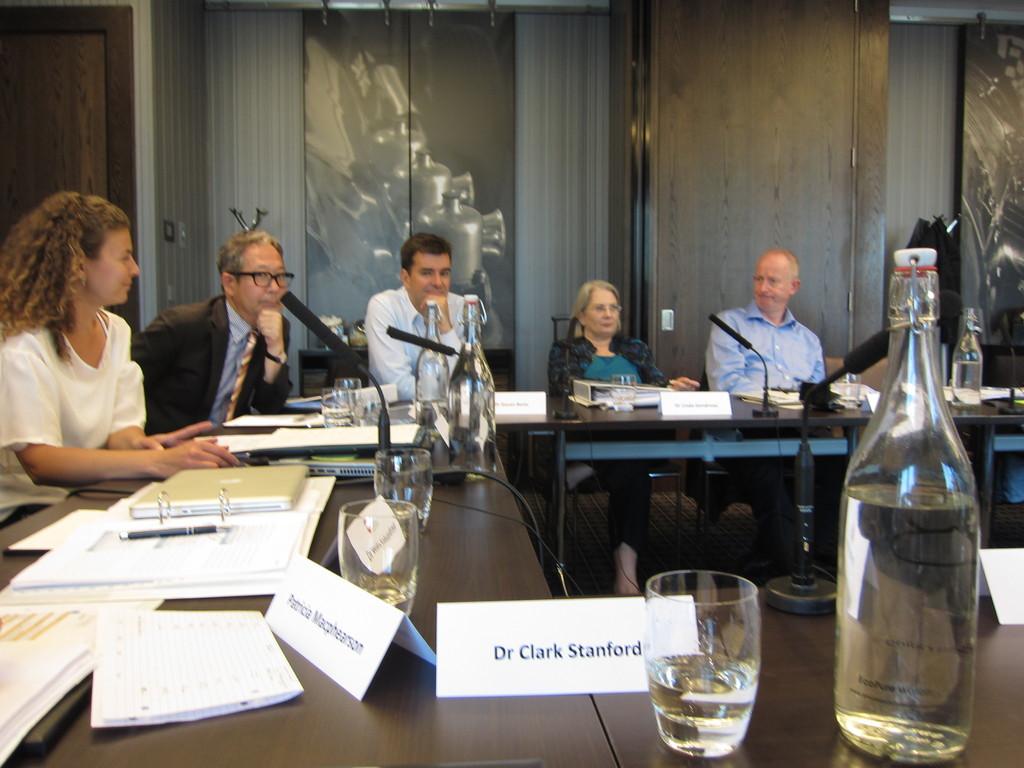What name is on the place card?
Provide a succinct answer. Dr clark stanford. 